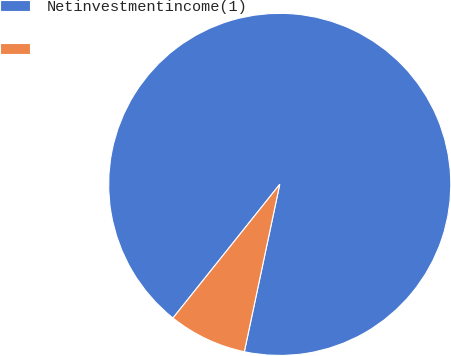Convert chart to OTSL. <chart><loc_0><loc_0><loc_500><loc_500><pie_chart><fcel>Netinvestmentincome(1)<fcel>Unnamed: 1<nl><fcel>92.59%<fcel>7.41%<nl></chart> 